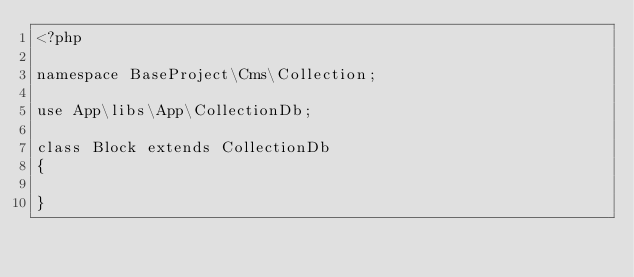<code> <loc_0><loc_0><loc_500><loc_500><_PHP_><?php

namespace BaseProject\Cms\Collection;

use App\libs\App\CollectionDb;

class Block extends CollectionDb
{

}</code> 